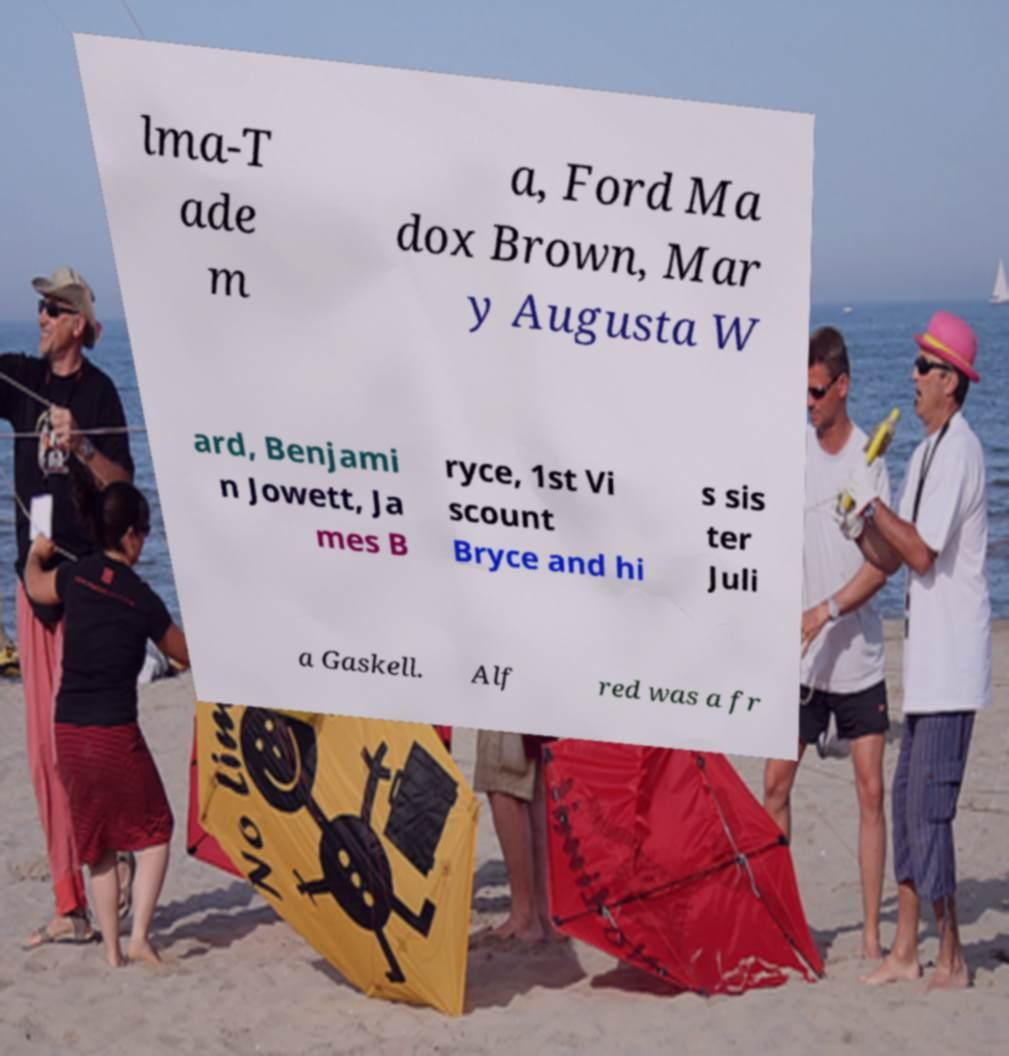Could you extract and type out the text from this image? lma-T ade m a, Ford Ma dox Brown, Mar y Augusta W ard, Benjami n Jowett, Ja mes B ryce, 1st Vi scount Bryce and hi s sis ter Juli a Gaskell. Alf red was a fr 